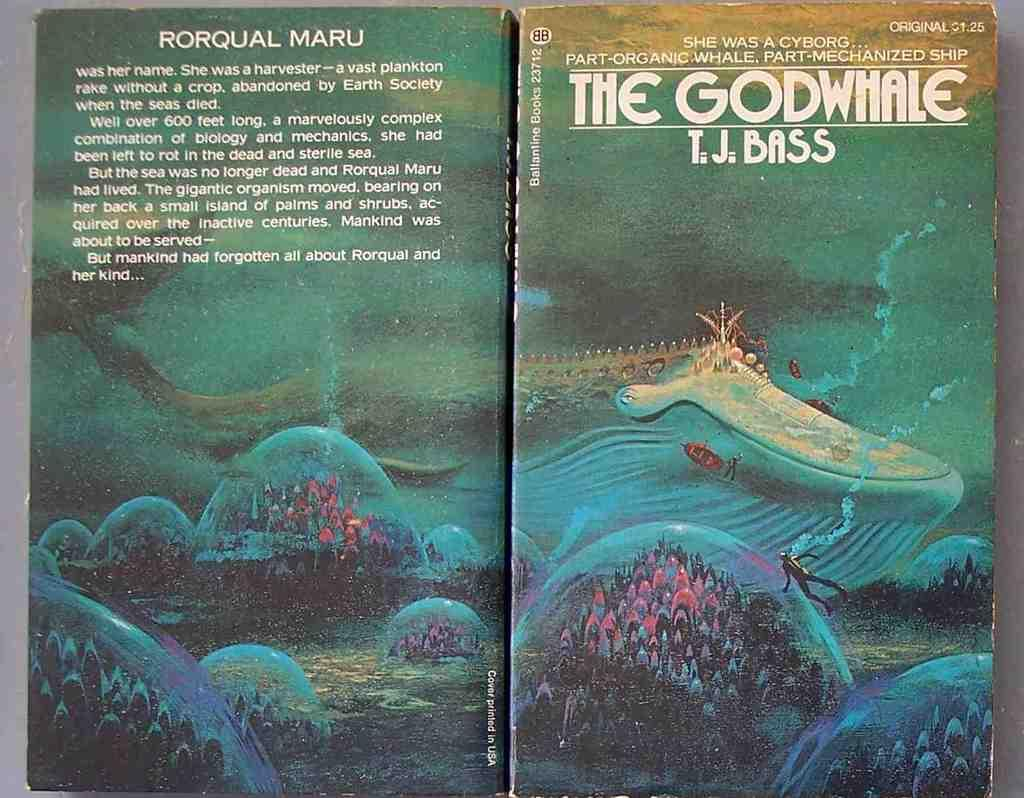<image>
Give a short and clear explanation of the subsequent image. A picture of a book title The Godwhale by T.J. Bass. 